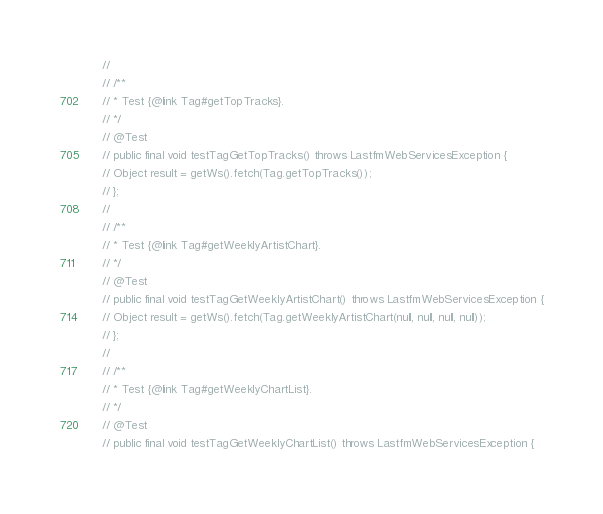<code> <loc_0><loc_0><loc_500><loc_500><_Java_>

	//
	// /**
	// * Test {@link Tag#getTopTracks}.
	// */
	// @Test
	// public final void testTagGetTopTracks() throws LastfmWebServicesException {
	// Object result = getWs().fetch(Tag.getTopTracks());
	// };
	//
	// /**
	// * Test {@link Tag#getWeeklyArtistChart}.
	// */
	// @Test
	// public final void testTagGetWeeklyArtistChart() throws LastfmWebServicesException {
	// Object result = getWs().fetch(Tag.getWeeklyArtistChart(null, null, null, null));
	// };
	//
	// /**
	// * Test {@link Tag#getWeeklyChartList}.
	// */
	// @Test
	// public final void testTagGetWeeklyChartList() throws LastfmWebServicesException {</code> 